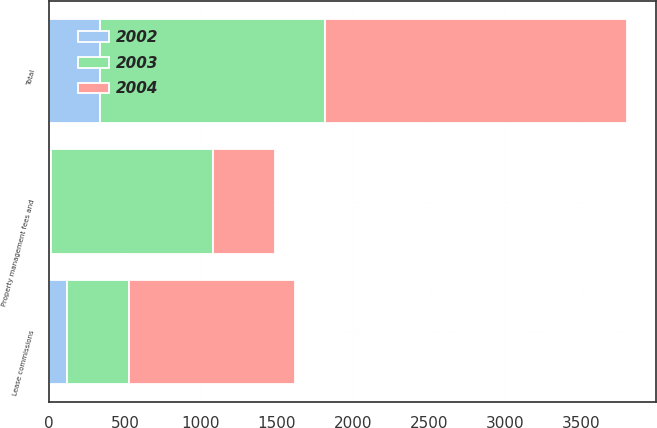Convert chart to OTSL. <chart><loc_0><loc_0><loc_500><loc_500><stacked_bar_chart><ecel><fcel>Lease commissions<fcel>Property management fees and<fcel>Total<nl><fcel>2003<fcel>411<fcel>1068<fcel>1479<nl><fcel>2004<fcel>1092<fcel>406<fcel>1989<nl><fcel>2002<fcel>116<fcel>11<fcel>335<nl></chart> 